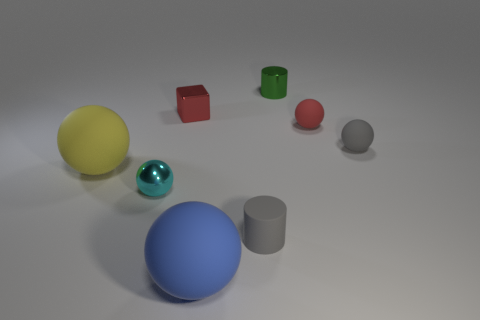Is there any other thing that has the same color as the tiny metallic cube?
Keep it short and to the point. Yes. What is the ball that is both behind the cyan object and on the left side of the green metal cylinder made of?
Provide a succinct answer. Rubber. There is a gray object that is behind the metal ball; what material is it?
Provide a short and direct response. Rubber. Are there fewer matte cylinders that are on the left side of the red block than big red metal objects?
Ensure brevity in your answer.  No. Is the shape of the large blue rubber object the same as the green metallic object?
Offer a terse response. No. Is there any other thing that is the same shape as the red metal thing?
Your answer should be very brief. No. Are there any tiny brown metallic cylinders?
Offer a very short reply. No. There is a large blue object; does it have the same shape as the tiny gray object on the right side of the tiny red rubber thing?
Provide a short and direct response. Yes. There is a tiny red object that is right of the large sphere that is to the right of the big yellow thing; what is it made of?
Your answer should be very brief. Rubber. The small cube is what color?
Keep it short and to the point. Red. 